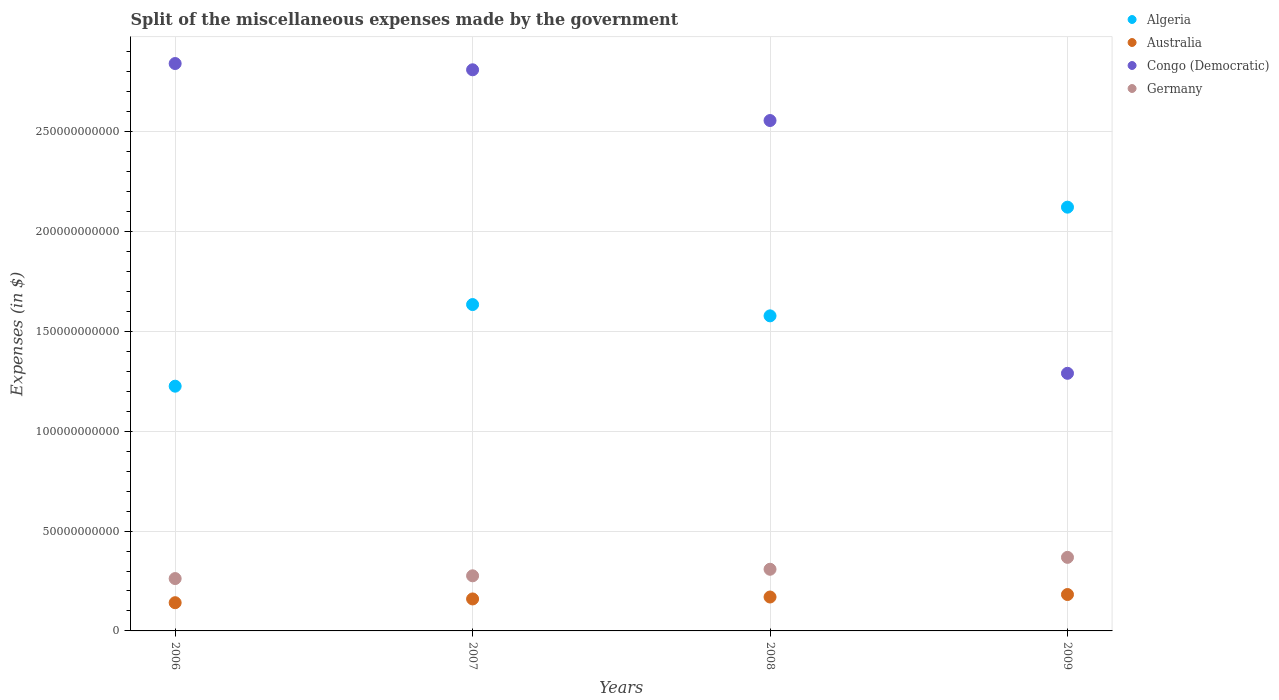How many different coloured dotlines are there?
Your response must be concise. 4. What is the miscellaneous expenses made by the government in Congo (Democratic) in 2009?
Your answer should be very brief. 1.29e+11. Across all years, what is the maximum miscellaneous expenses made by the government in Germany?
Your answer should be compact. 3.68e+1. Across all years, what is the minimum miscellaneous expenses made by the government in Germany?
Your answer should be compact. 2.62e+1. In which year was the miscellaneous expenses made by the government in Australia maximum?
Your answer should be very brief. 2009. In which year was the miscellaneous expenses made by the government in Germany minimum?
Offer a terse response. 2006. What is the total miscellaneous expenses made by the government in Algeria in the graph?
Give a very brief answer. 6.56e+11. What is the difference between the miscellaneous expenses made by the government in Algeria in 2007 and that in 2008?
Ensure brevity in your answer.  5.66e+09. What is the difference between the miscellaneous expenses made by the government in Congo (Democratic) in 2008 and the miscellaneous expenses made by the government in Algeria in 2009?
Make the answer very short. 4.34e+1. What is the average miscellaneous expenses made by the government in Australia per year?
Give a very brief answer. 1.63e+1. In the year 2007, what is the difference between the miscellaneous expenses made by the government in Australia and miscellaneous expenses made by the government in Germany?
Provide a succinct answer. -1.16e+1. What is the ratio of the miscellaneous expenses made by the government in Germany in 2007 to that in 2009?
Your response must be concise. 0.75. Is the miscellaneous expenses made by the government in Congo (Democratic) in 2007 less than that in 2009?
Ensure brevity in your answer.  No. What is the difference between the highest and the second highest miscellaneous expenses made by the government in Germany?
Make the answer very short. 5.96e+09. What is the difference between the highest and the lowest miscellaneous expenses made by the government in Congo (Democratic)?
Your answer should be compact. 1.55e+11. In how many years, is the miscellaneous expenses made by the government in Congo (Democratic) greater than the average miscellaneous expenses made by the government in Congo (Democratic) taken over all years?
Offer a terse response. 3. Is it the case that in every year, the sum of the miscellaneous expenses made by the government in Germany and miscellaneous expenses made by the government in Congo (Democratic)  is greater than the sum of miscellaneous expenses made by the government in Australia and miscellaneous expenses made by the government in Algeria?
Offer a terse response. Yes. Is it the case that in every year, the sum of the miscellaneous expenses made by the government in Congo (Democratic) and miscellaneous expenses made by the government in Germany  is greater than the miscellaneous expenses made by the government in Algeria?
Your answer should be very brief. No. Does the miscellaneous expenses made by the government in Congo (Democratic) monotonically increase over the years?
Your response must be concise. No. Is the miscellaneous expenses made by the government in Germany strictly greater than the miscellaneous expenses made by the government in Congo (Democratic) over the years?
Provide a succinct answer. No. How many dotlines are there?
Give a very brief answer. 4. How many years are there in the graph?
Your answer should be very brief. 4. Are the values on the major ticks of Y-axis written in scientific E-notation?
Offer a very short reply. No. What is the title of the graph?
Your answer should be compact. Split of the miscellaneous expenses made by the government. What is the label or title of the Y-axis?
Provide a succinct answer. Expenses (in $). What is the Expenses (in $) in Algeria in 2006?
Offer a very short reply. 1.23e+11. What is the Expenses (in $) of Australia in 2006?
Offer a very short reply. 1.41e+1. What is the Expenses (in $) in Congo (Democratic) in 2006?
Offer a very short reply. 2.84e+11. What is the Expenses (in $) of Germany in 2006?
Offer a terse response. 2.62e+1. What is the Expenses (in $) of Algeria in 2007?
Make the answer very short. 1.63e+11. What is the Expenses (in $) of Australia in 2007?
Your answer should be very brief. 1.60e+1. What is the Expenses (in $) of Congo (Democratic) in 2007?
Ensure brevity in your answer.  2.81e+11. What is the Expenses (in $) in Germany in 2007?
Give a very brief answer. 2.76e+1. What is the Expenses (in $) of Algeria in 2008?
Your response must be concise. 1.58e+11. What is the Expenses (in $) in Australia in 2008?
Make the answer very short. 1.70e+1. What is the Expenses (in $) of Congo (Democratic) in 2008?
Offer a very short reply. 2.56e+11. What is the Expenses (in $) of Germany in 2008?
Provide a short and direct response. 3.09e+1. What is the Expenses (in $) in Algeria in 2009?
Provide a succinct answer. 2.12e+11. What is the Expenses (in $) of Australia in 2009?
Keep it short and to the point. 1.82e+1. What is the Expenses (in $) in Congo (Democratic) in 2009?
Ensure brevity in your answer.  1.29e+11. What is the Expenses (in $) of Germany in 2009?
Offer a very short reply. 3.68e+1. Across all years, what is the maximum Expenses (in $) of Algeria?
Offer a very short reply. 2.12e+11. Across all years, what is the maximum Expenses (in $) in Australia?
Keep it short and to the point. 1.82e+1. Across all years, what is the maximum Expenses (in $) in Congo (Democratic)?
Provide a short and direct response. 2.84e+11. Across all years, what is the maximum Expenses (in $) in Germany?
Provide a short and direct response. 3.68e+1. Across all years, what is the minimum Expenses (in $) in Algeria?
Provide a short and direct response. 1.23e+11. Across all years, what is the minimum Expenses (in $) of Australia?
Your response must be concise. 1.41e+1. Across all years, what is the minimum Expenses (in $) of Congo (Democratic)?
Your answer should be very brief. 1.29e+11. Across all years, what is the minimum Expenses (in $) of Germany?
Provide a short and direct response. 2.62e+1. What is the total Expenses (in $) of Algeria in the graph?
Provide a succinct answer. 6.56e+11. What is the total Expenses (in $) of Australia in the graph?
Offer a terse response. 6.54e+1. What is the total Expenses (in $) in Congo (Democratic) in the graph?
Provide a short and direct response. 9.50e+11. What is the total Expenses (in $) in Germany in the graph?
Keep it short and to the point. 1.22e+11. What is the difference between the Expenses (in $) in Algeria in 2006 and that in 2007?
Ensure brevity in your answer.  -4.09e+1. What is the difference between the Expenses (in $) of Australia in 2006 and that in 2007?
Your answer should be very brief. -1.88e+09. What is the difference between the Expenses (in $) in Congo (Democratic) in 2006 and that in 2007?
Your answer should be compact. 3.14e+09. What is the difference between the Expenses (in $) of Germany in 2006 and that in 2007?
Offer a very short reply. -1.38e+09. What is the difference between the Expenses (in $) in Algeria in 2006 and that in 2008?
Offer a very short reply. -3.52e+1. What is the difference between the Expenses (in $) of Australia in 2006 and that in 2008?
Provide a succinct answer. -2.85e+09. What is the difference between the Expenses (in $) of Congo (Democratic) in 2006 and that in 2008?
Ensure brevity in your answer.  2.85e+1. What is the difference between the Expenses (in $) of Germany in 2006 and that in 2008?
Your answer should be very brief. -4.66e+09. What is the difference between the Expenses (in $) of Algeria in 2006 and that in 2009?
Your answer should be very brief. -8.96e+1. What is the difference between the Expenses (in $) of Australia in 2006 and that in 2009?
Provide a succinct answer. -4.10e+09. What is the difference between the Expenses (in $) in Congo (Democratic) in 2006 and that in 2009?
Your answer should be compact. 1.55e+11. What is the difference between the Expenses (in $) of Germany in 2006 and that in 2009?
Give a very brief answer. -1.06e+1. What is the difference between the Expenses (in $) in Algeria in 2007 and that in 2008?
Make the answer very short. 5.66e+09. What is the difference between the Expenses (in $) in Australia in 2007 and that in 2008?
Make the answer very short. -9.65e+08. What is the difference between the Expenses (in $) in Congo (Democratic) in 2007 and that in 2008?
Your answer should be compact. 2.54e+1. What is the difference between the Expenses (in $) in Germany in 2007 and that in 2008?
Provide a succinct answer. -3.28e+09. What is the difference between the Expenses (in $) in Algeria in 2007 and that in 2009?
Provide a short and direct response. -4.88e+1. What is the difference between the Expenses (in $) of Australia in 2007 and that in 2009?
Keep it short and to the point. -2.21e+09. What is the difference between the Expenses (in $) of Congo (Democratic) in 2007 and that in 2009?
Your answer should be very brief. 1.52e+11. What is the difference between the Expenses (in $) of Germany in 2007 and that in 2009?
Make the answer very short. -9.24e+09. What is the difference between the Expenses (in $) in Algeria in 2008 and that in 2009?
Provide a succinct answer. -5.44e+1. What is the difference between the Expenses (in $) in Australia in 2008 and that in 2009?
Provide a short and direct response. -1.25e+09. What is the difference between the Expenses (in $) in Congo (Democratic) in 2008 and that in 2009?
Give a very brief answer. 1.27e+11. What is the difference between the Expenses (in $) in Germany in 2008 and that in 2009?
Ensure brevity in your answer.  -5.96e+09. What is the difference between the Expenses (in $) in Algeria in 2006 and the Expenses (in $) in Australia in 2007?
Ensure brevity in your answer.  1.07e+11. What is the difference between the Expenses (in $) of Algeria in 2006 and the Expenses (in $) of Congo (Democratic) in 2007?
Offer a terse response. -1.58e+11. What is the difference between the Expenses (in $) of Algeria in 2006 and the Expenses (in $) of Germany in 2007?
Keep it short and to the point. 9.50e+1. What is the difference between the Expenses (in $) in Australia in 2006 and the Expenses (in $) in Congo (Democratic) in 2007?
Keep it short and to the point. -2.67e+11. What is the difference between the Expenses (in $) of Australia in 2006 and the Expenses (in $) of Germany in 2007?
Your response must be concise. -1.35e+1. What is the difference between the Expenses (in $) in Congo (Democratic) in 2006 and the Expenses (in $) in Germany in 2007?
Make the answer very short. 2.57e+11. What is the difference between the Expenses (in $) in Algeria in 2006 and the Expenses (in $) in Australia in 2008?
Give a very brief answer. 1.06e+11. What is the difference between the Expenses (in $) of Algeria in 2006 and the Expenses (in $) of Congo (Democratic) in 2008?
Ensure brevity in your answer.  -1.33e+11. What is the difference between the Expenses (in $) in Algeria in 2006 and the Expenses (in $) in Germany in 2008?
Offer a very short reply. 9.17e+1. What is the difference between the Expenses (in $) in Australia in 2006 and the Expenses (in $) in Congo (Democratic) in 2008?
Keep it short and to the point. -2.41e+11. What is the difference between the Expenses (in $) of Australia in 2006 and the Expenses (in $) of Germany in 2008?
Keep it short and to the point. -1.68e+1. What is the difference between the Expenses (in $) in Congo (Democratic) in 2006 and the Expenses (in $) in Germany in 2008?
Provide a short and direct response. 2.53e+11. What is the difference between the Expenses (in $) of Algeria in 2006 and the Expenses (in $) of Australia in 2009?
Your response must be concise. 1.04e+11. What is the difference between the Expenses (in $) in Algeria in 2006 and the Expenses (in $) in Congo (Democratic) in 2009?
Your response must be concise. -6.45e+09. What is the difference between the Expenses (in $) of Algeria in 2006 and the Expenses (in $) of Germany in 2009?
Your answer should be very brief. 8.57e+1. What is the difference between the Expenses (in $) of Australia in 2006 and the Expenses (in $) of Congo (Democratic) in 2009?
Make the answer very short. -1.15e+11. What is the difference between the Expenses (in $) in Australia in 2006 and the Expenses (in $) in Germany in 2009?
Offer a terse response. -2.27e+1. What is the difference between the Expenses (in $) of Congo (Democratic) in 2006 and the Expenses (in $) of Germany in 2009?
Your answer should be very brief. 2.47e+11. What is the difference between the Expenses (in $) of Algeria in 2007 and the Expenses (in $) of Australia in 2008?
Your response must be concise. 1.46e+11. What is the difference between the Expenses (in $) of Algeria in 2007 and the Expenses (in $) of Congo (Democratic) in 2008?
Offer a very short reply. -9.22e+1. What is the difference between the Expenses (in $) in Algeria in 2007 and the Expenses (in $) in Germany in 2008?
Provide a short and direct response. 1.33e+11. What is the difference between the Expenses (in $) of Australia in 2007 and the Expenses (in $) of Congo (Democratic) in 2008?
Your answer should be compact. -2.40e+11. What is the difference between the Expenses (in $) of Australia in 2007 and the Expenses (in $) of Germany in 2008?
Your response must be concise. -1.49e+1. What is the difference between the Expenses (in $) in Congo (Democratic) in 2007 and the Expenses (in $) in Germany in 2008?
Give a very brief answer. 2.50e+11. What is the difference between the Expenses (in $) in Algeria in 2007 and the Expenses (in $) in Australia in 2009?
Provide a short and direct response. 1.45e+11. What is the difference between the Expenses (in $) in Algeria in 2007 and the Expenses (in $) in Congo (Democratic) in 2009?
Offer a terse response. 3.44e+1. What is the difference between the Expenses (in $) of Algeria in 2007 and the Expenses (in $) of Germany in 2009?
Give a very brief answer. 1.27e+11. What is the difference between the Expenses (in $) of Australia in 2007 and the Expenses (in $) of Congo (Democratic) in 2009?
Your response must be concise. -1.13e+11. What is the difference between the Expenses (in $) of Australia in 2007 and the Expenses (in $) of Germany in 2009?
Your answer should be compact. -2.08e+1. What is the difference between the Expenses (in $) of Congo (Democratic) in 2007 and the Expenses (in $) of Germany in 2009?
Offer a terse response. 2.44e+11. What is the difference between the Expenses (in $) in Algeria in 2008 and the Expenses (in $) in Australia in 2009?
Your answer should be very brief. 1.40e+11. What is the difference between the Expenses (in $) in Algeria in 2008 and the Expenses (in $) in Congo (Democratic) in 2009?
Ensure brevity in your answer.  2.88e+1. What is the difference between the Expenses (in $) in Algeria in 2008 and the Expenses (in $) in Germany in 2009?
Ensure brevity in your answer.  1.21e+11. What is the difference between the Expenses (in $) of Australia in 2008 and the Expenses (in $) of Congo (Democratic) in 2009?
Ensure brevity in your answer.  -1.12e+11. What is the difference between the Expenses (in $) in Australia in 2008 and the Expenses (in $) in Germany in 2009?
Provide a short and direct response. -1.99e+1. What is the difference between the Expenses (in $) in Congo (Democratic) in 2008 and the Expenses (in $) in Germany in 2009?
Ensure brevity in your answer.  2.19e+11. What is the average Expenses (in $) in Algeria per year?
Provide a short and direct response. 1.64e+11. What is the average Expenses (in $) of Australia per year?
Offer a terse response. 1.63e+1. What is the average Expenses (in $) in Congo (Democratic) per year?
Your answer should be compact. 2.37e+11. What is the average Expenses (in $) of Germany per year?
Make the answer very short. 3.04e+1. In the year 2006, what is the difference between the Expenses (in $) in Algeria and Expenses (in $) in Australia?
Keep it short and to the point. 1.08e+11. In the year 2006, what is the difference between the Expenses (in $) in Algeria and Expenses (in $) in Congo (Democratic)?
Provide a succinct answer. -1.62e+11. In the year 2006, what is the difference between the Expenses (in $) in Algeria and Expenses (in $) in Germany?
Give a very brief answer. 9.63e+1. In the year 2006, what is the difference between the Expenses (in $) in Australia and Expenses (in $) in Congo (Democratic)?
Ensure brevity in your answer.  -2.70e+11. In the year 2006, what is the difference between the Expenses (in $) in Australia and Expenses (in $) in Germany?
Your answer should be compact. -1.21e+1. In the year 2006, what is the difference between the Expenses (in $) in Congo (Democratic) and Expenses (in $) in Germany?
Provide a short and direct response. 2.58e+11. In the year 2007, what is the difference between the Expenses (in $) of Algeria and Expenses (in $) of Australia?
Provide a short and direct response. 1.47e+11. In the year 2007, what is the difference between the Expenses (in $) of Algeria and Expenses (in $) of Congo (Democratic)?
Keep it short and to the point. -1.18e+11. In the year 2007, what is the difference between the Expenses (in $) in Algeria and Expenses (in $) in Germany?
Offer a terse response. 1.36e+11. In the year 2007, what is the difference between the Expenses (in $) in Australia and Expenses (in $) in Congo (Democratic)?
Provide a succinct answer. -2.65e+11. In the year 2007, what is the difference between the Expenses (in $) of Australia and Expenses (in $) of Germany?
Offer a terse response. -1.16e+1. In the year 2007, what is the difference between the Expenses (in $) of Congo (Democratic) and Expenses (in $) of Germany?
Your answer should be very brief. 2.53e+11. In the year 2008, what is the difference between the Expenses (in $) in Algeria and Expenses (in $) in Australia?
Offer a terse response. 1.41e+11. In the year 2008, what is the difference between the Expenses (in $) of Algeria and Expenses (in $) of Congo (Democratic)?
Offer a very short reply. -9.78e+1. In the year 2008, what is the difference between the Expenses (in $) in Algeria and Expenses (in $) in Germany?
Give a very brief answer. 1.27e+11. In the year 2008, what is the difference between the Expenses (in $) of Australia and Expenses (in $) of Congo (Democratic)?
Your answer should be very brief. -2.39e+11. In the year 2008, what is the difference between the Expenses (in $) of Australia and Expenses (in $) of Germany?
Ensure brevity in your answer.  -1.39e+1. In the year 2008, what is the difference between the Expenses (in $) in Congo (Democratic) and Expenses (in $) in Germany?
Ensure brevity in your answer.  2.25e+11. In the year 2009, what is the difference between the Expenses (in $) of Algeria and Expenses (in $) of Australia?
Your answer should be very brief. 1.94e+11. In the year 2009, what is the difference between the Expenses (in $) of Algeria and Expenses (in $) of Congo (Democratic)?
Provide a succinct answer. 8.32e+1. In the year 2009, what is the difference between the Expenses (in $) in Algeria and Expenses (in $) in Germany?
Your answer should be compact. 1.75e+11. In the year 2009, what is the difference between the Expenses (in $) of Australia and Expenses (in $) of Congo (Democratic)?
Your response must be concise. -1.11e+11. In the year 2009, what is the difference between the Expenses (in $) in Australia and Expenses (in $) in Germany?
Your response must be concise. -1.86e+1. In the year 2009, what is the difference between the Expenses (in $) of Congo (Democratic) and Expenses (in $) of Germany?
Your response must be concise. 9.22e+1. What is the ratio of the Expenses (in $) of Algeria in 2006 to that in 2007?
Offer a terse response. 0.75. What is the ratio of the Expenses (in $) of Australia in 2006 to that in 2007?
Make the answer very short. 0.88. What is the ratio of the Expenses (in $) of Congo (Democratic) in 2006 to that in 2007?
Provide a succinct answer. 1.01. What is the ratio of the Expenses (in $) of Germany in 2006 to that in 2007?
Offer a very short reply. 0.95. What is the ratio of the Expenses (in $) of Algeria in 2006 to that in 2008?
Give a very brief answer. 0.78. What is the ratio of the Expenses (in $) in Australia in 2006 to that in 2008?
Provide a succinct answer. 0.83. What is the ratio of the Expenses (in $) in Congo (Democratic) in 2006 to that in 2008?
Ensure brevity in your answer.  1.11. What is the ratio of the Expenses (in $) in Germany in 2006 to that in 2008?
Ensure brevity in your answer.  0.85. What is the ratio of the Expenses (in $) of Algeria in 2006 to that in 2009?
Provide a succinct answer. 0.58. What is the ratio of the Expenses (in $) of Australia in 2006 to that in 2009?
Ensure brevity in your answer.  0.78. What is the ratio of the Expenses (in $) of Congo (Democratic) in 2006 to that in 2009?
Your answer should be very brief. 2.2. What is the ratio of the Expenses (in $) of Germany in 2006 to that in 2009?
Make the answer very short. 0.71. What is the ratio of the Expenses (in $) of Algeria in 2007 to that in 2008?
Provide a short and direct response. 1.04. What is the ratio of the Expenses (in $) of Australia in 2007 to that in 2008?
Your answer should be compact. 0.94. What is the ratio of the Expenses (in $) of Congo (Democratic) in 2007 to that in 2008?
Provide a short and direct response. 1.1. What is the ratio of the Expenses (in $) in Germany in 2007 to that in 2008?
Offer a terse response. 0.89. What is the ratio of the Expenses (in $) in Algeria in 2007 to that in 2009?
Your response must be concise. 0.77. What is the ratio of the Expenses (in $) of Australia in 2007 to that in 2009?
Ensure brevity in your answer.  0.88. What is the ratio of the Expenses (in $) of Congo (Democratic) in 2007 to that in 2009?
Your response must be concise. 2.18. What is the ratio of the Expenses (in $) of Germany in 2007 to that in 2009?
Ensure brevity in your answer.  0.75. What is the ratio of the Expenses (in $) in Algeria in 2008 to that in 2009?
Offer a very short reply. 0.74. What is the ratio of the Expenses (in $) in Australia in 2008 to that in 2009?
Your answer should be compact. 0.93. What is the ratio of the Expenses (in $) of Congo (Democratic) in 2008 to that in 2009?
Provide a succinct answer. 1.98. What is the ratio of the Expenses (in $) of Germany in 2008 to that in 2009?
Ensure brevity in your answer.  0.84. What is the difference between the highest and the second highest Expenses (in $) in Algeria?
Offer a very short reply. 4.88e+1. What is the difference between the highest and the second highest Expenses (in $) in Australia?
Offer a very short reply. 1.25e+09. What is the difference between the highest and the second highest Expenses (in $) of Congo (Democratic)?
Keep it short and to the point. 3.14e+09. What is the difference between the highest and the second highest Expenses (in $) in Germany?
Offer a very short reply. 5.96e+09. What is the difference between the highest and the lowest Expenses (in $) in Algeria?
Ensure brevity in your answer.  8.96e+1. What is the difference between the highest and the lowest Expenses (in $) in Australia?
Offer a terse response. 4.10e+09. What is the difference between the highest and the lowest Expenses (in $) in Congo (Democratic)?
Your response must be concise. 1.55e+11. What is the difference between the highest and the lowest Expenses (in $) in Germany?
Your answer should be very brief. 1.06e+1. 